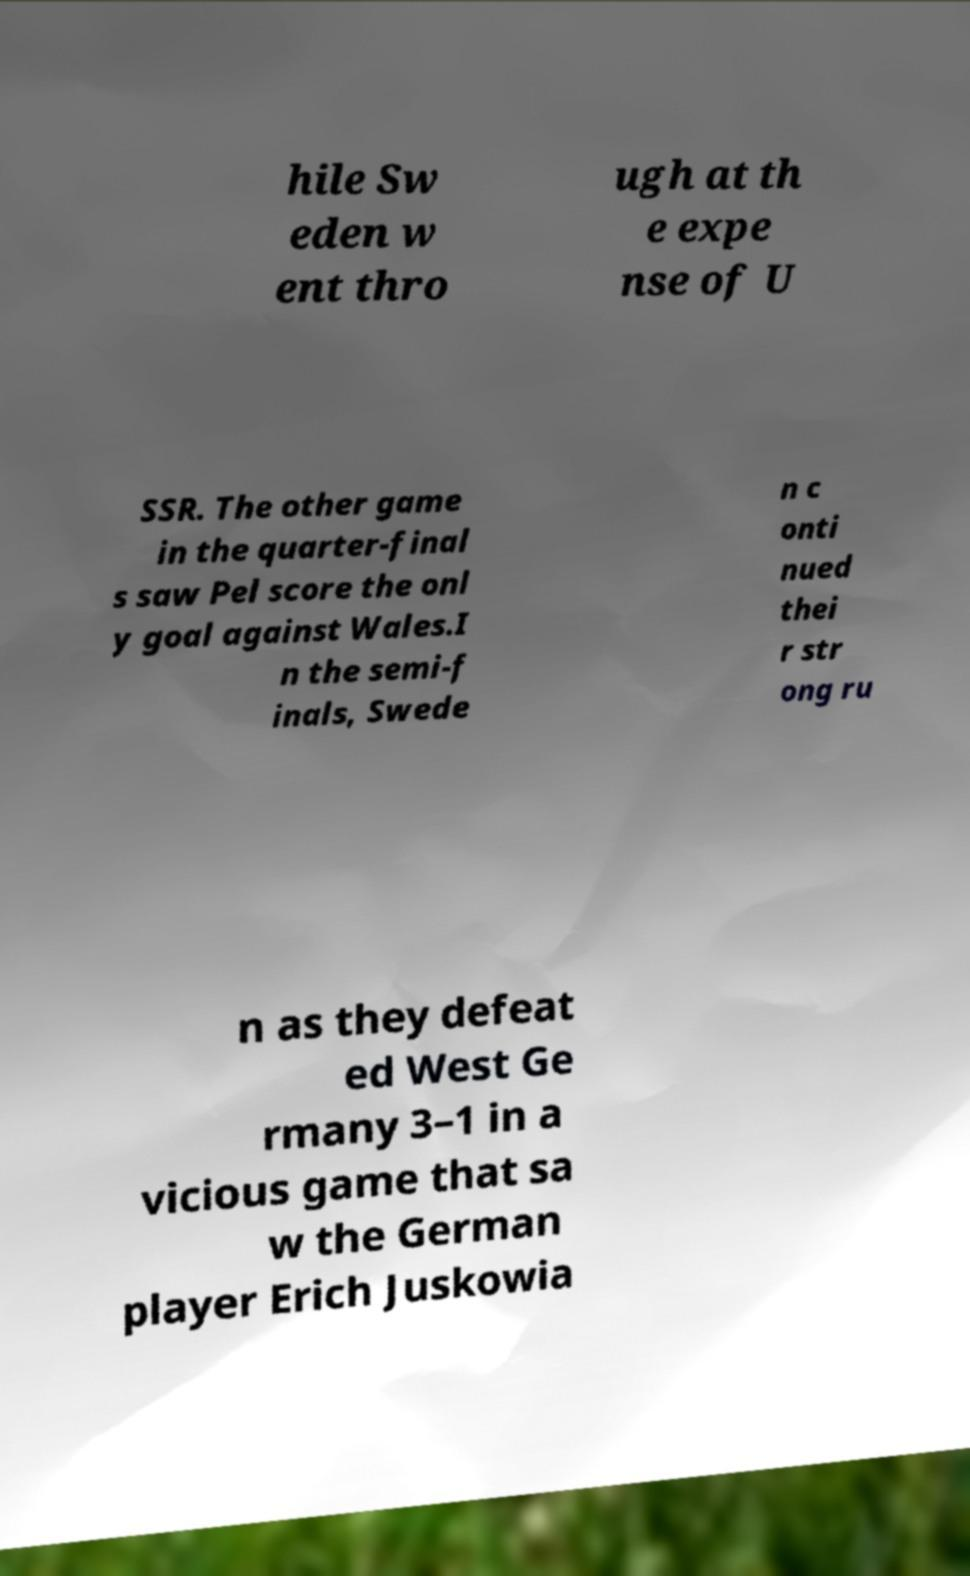For documentation purposes, I need the text within this image transcribed. Could you provide that? hile Sw eden w ent thro ugh at th e expe nse of U SSR. The other game in the quarter-final s saw Pel score the onl y goal against Wales.I n the semi-f inals, Swede n c onti nued thei r str ong ru n as they defeat ed West Ge rmany 3–1 in a vicious game that sa w the German player Erich Juskowia 